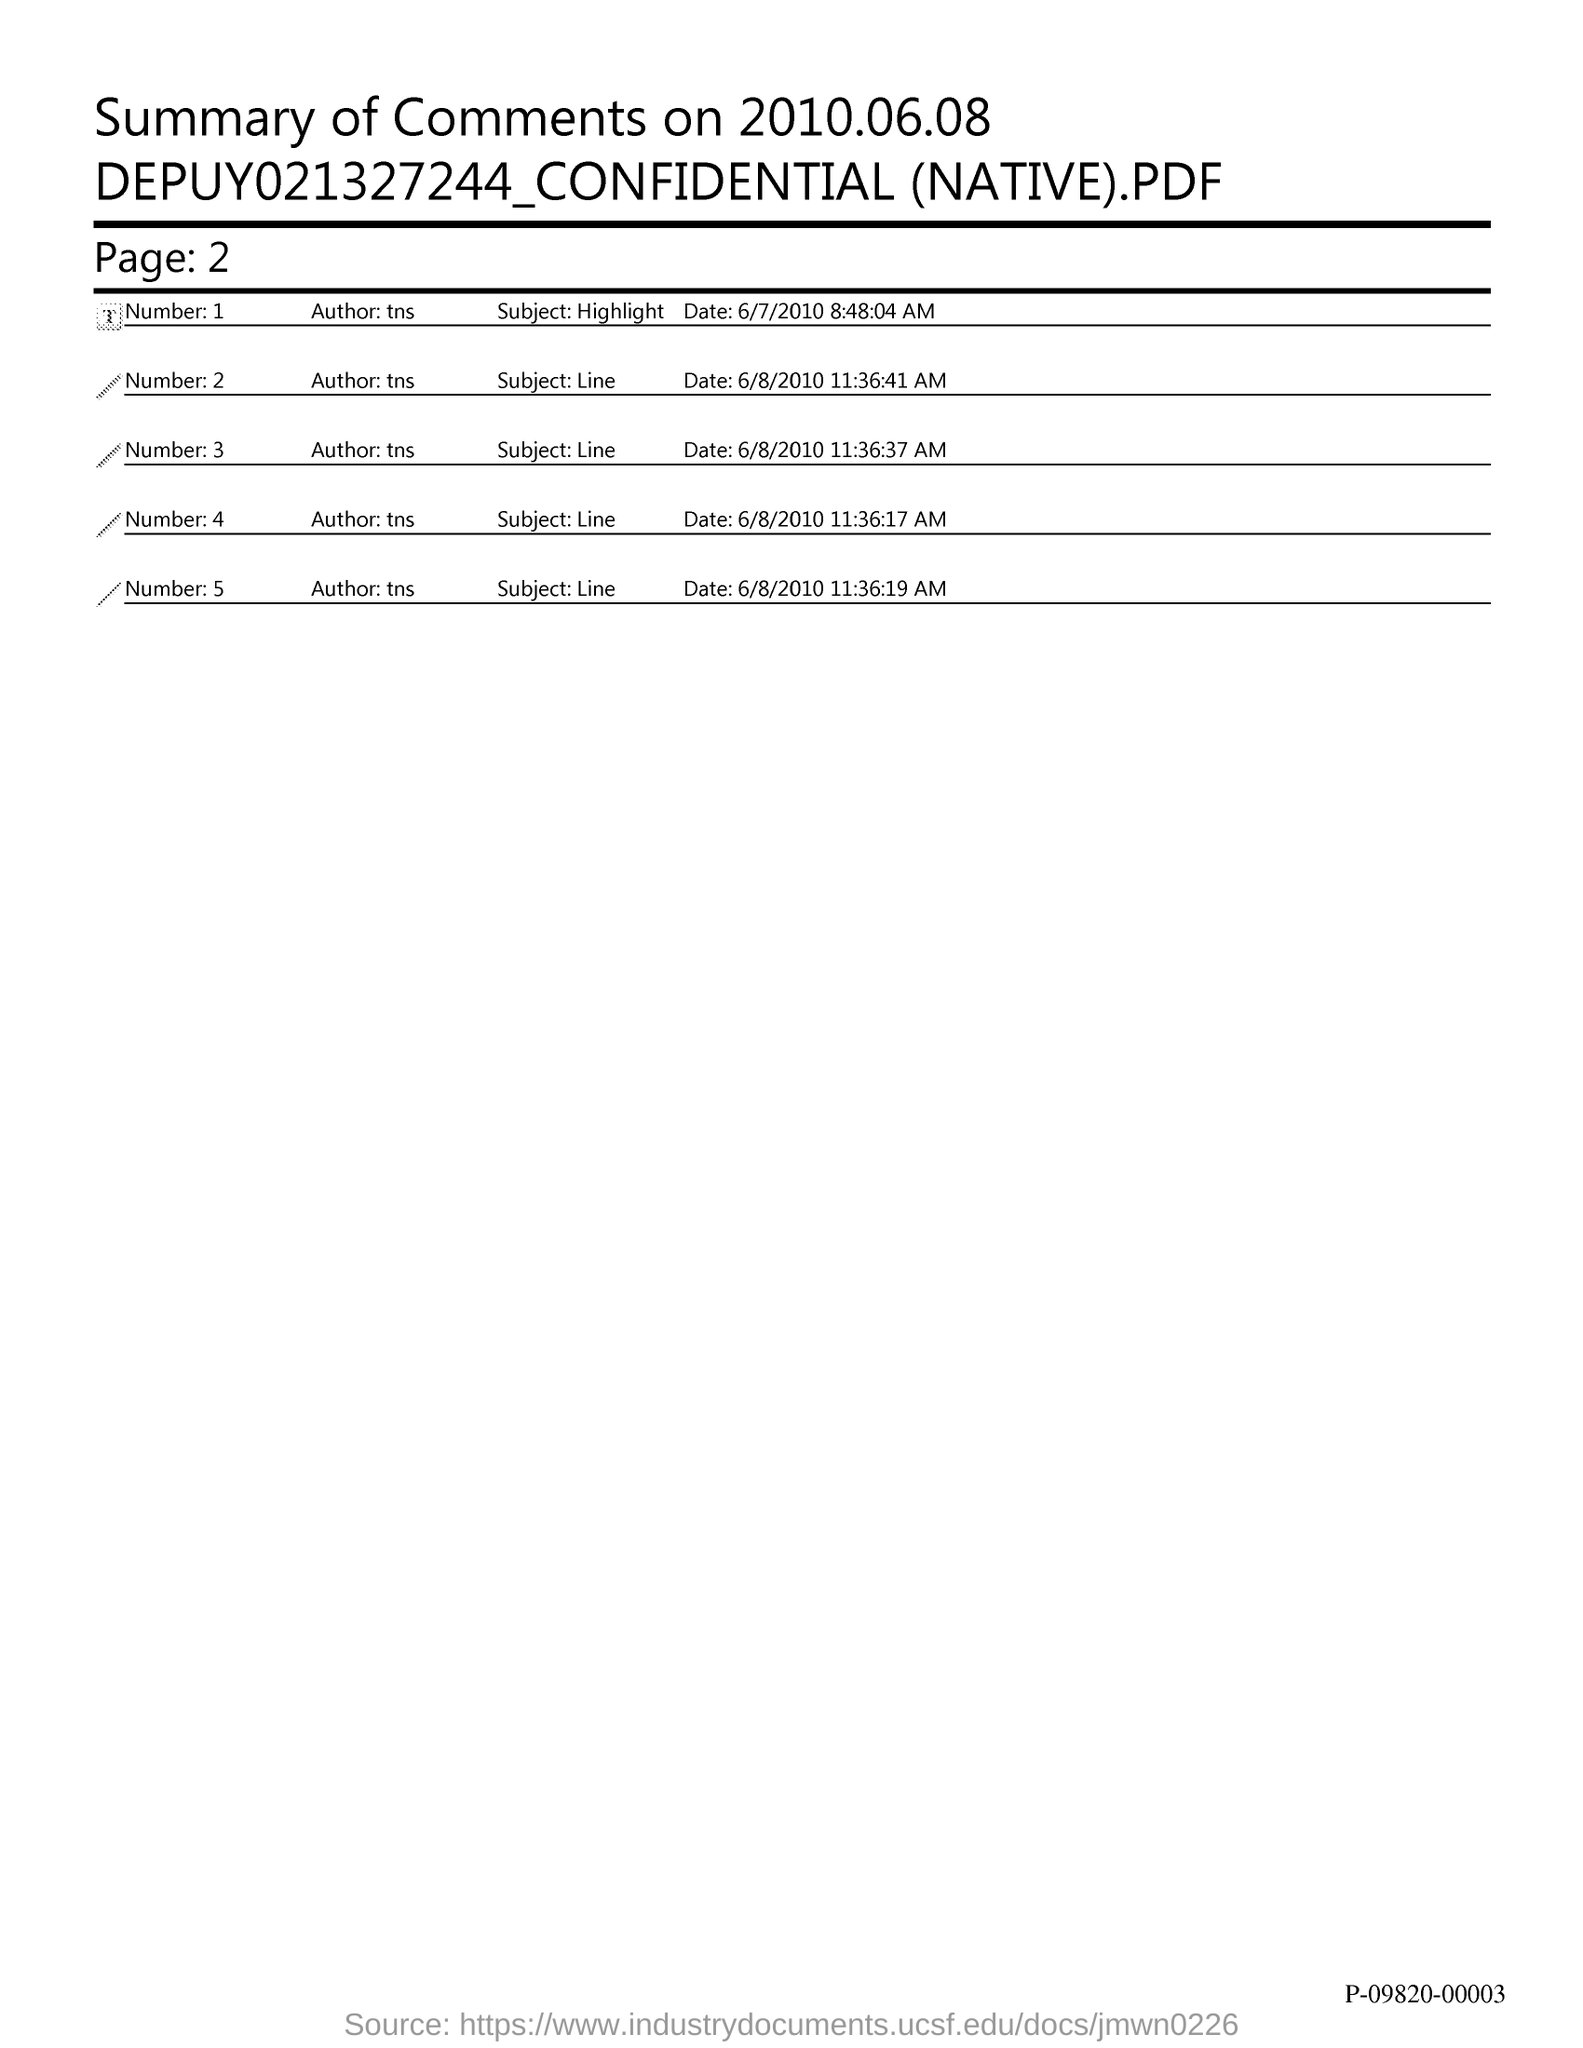The summary of comments for when?
Your response must be concise. 2010.06.08. What is the Page?
Ensure brevity in your answer.  2. 